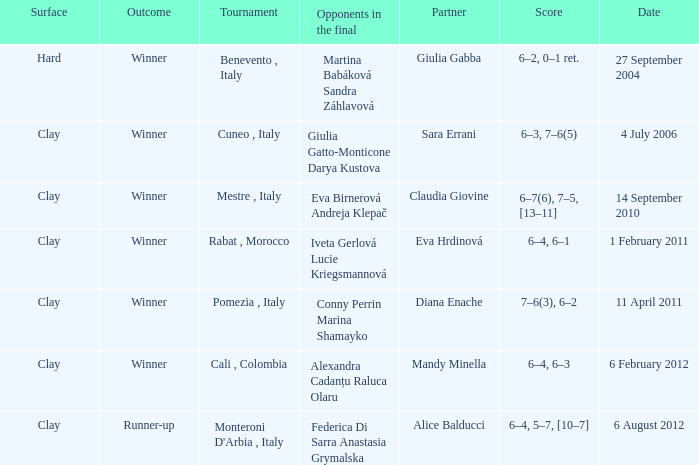Who played on a hard surface? Giulia Gabba. 